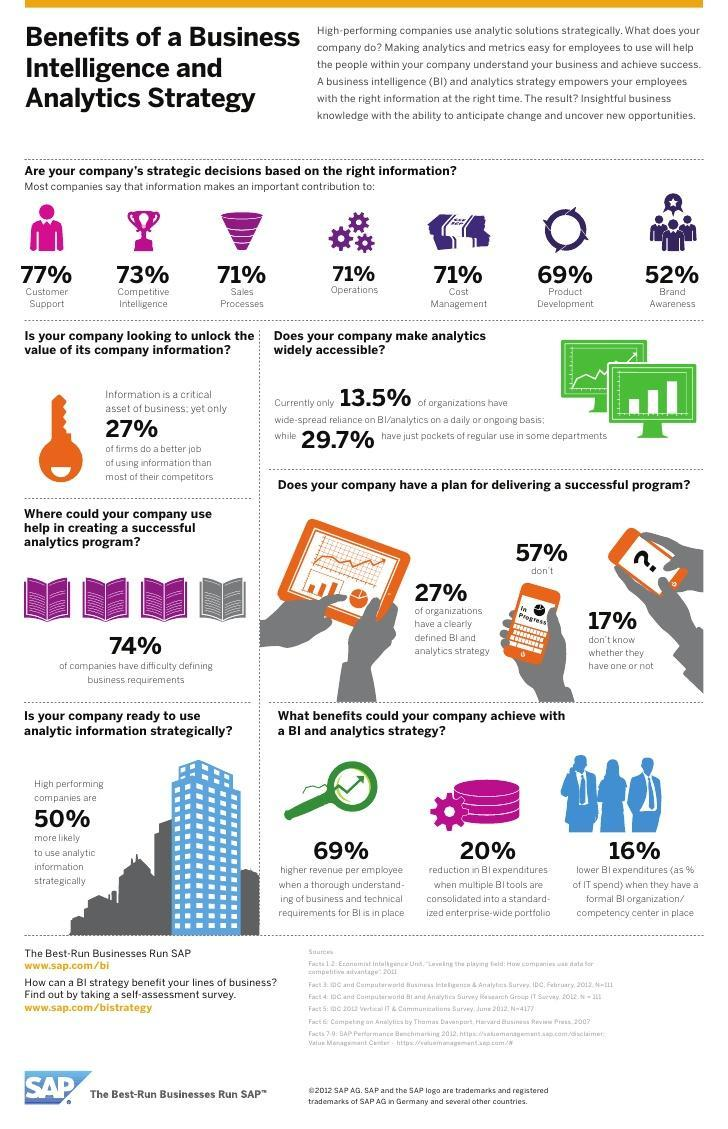What percentage of organizations have considerable reliance on Business Intelligence, for their day to day operations ?
Answer the question with a short phrase. 13.5% What percentage of companies dont  have a clearly defined business intelligence and analytics stratgey and know that they dont have? 57% What percentage of companies are in doubt if they have a clearly defined business intelligence and analytics stratgey? 17% What percentage of companies have opined that information is useful for their operations? 71% What percentage of companies face difficulty in defining their business requirements? 74% What percentage of comapnies said that "information" is useful for their cost management? 71% What percentage of organizations have a clearly deifined business intelligence and analytics strategy? 27% What is shown on the display of the orange colored  mobile phone shown below  "57%" ? in progress 